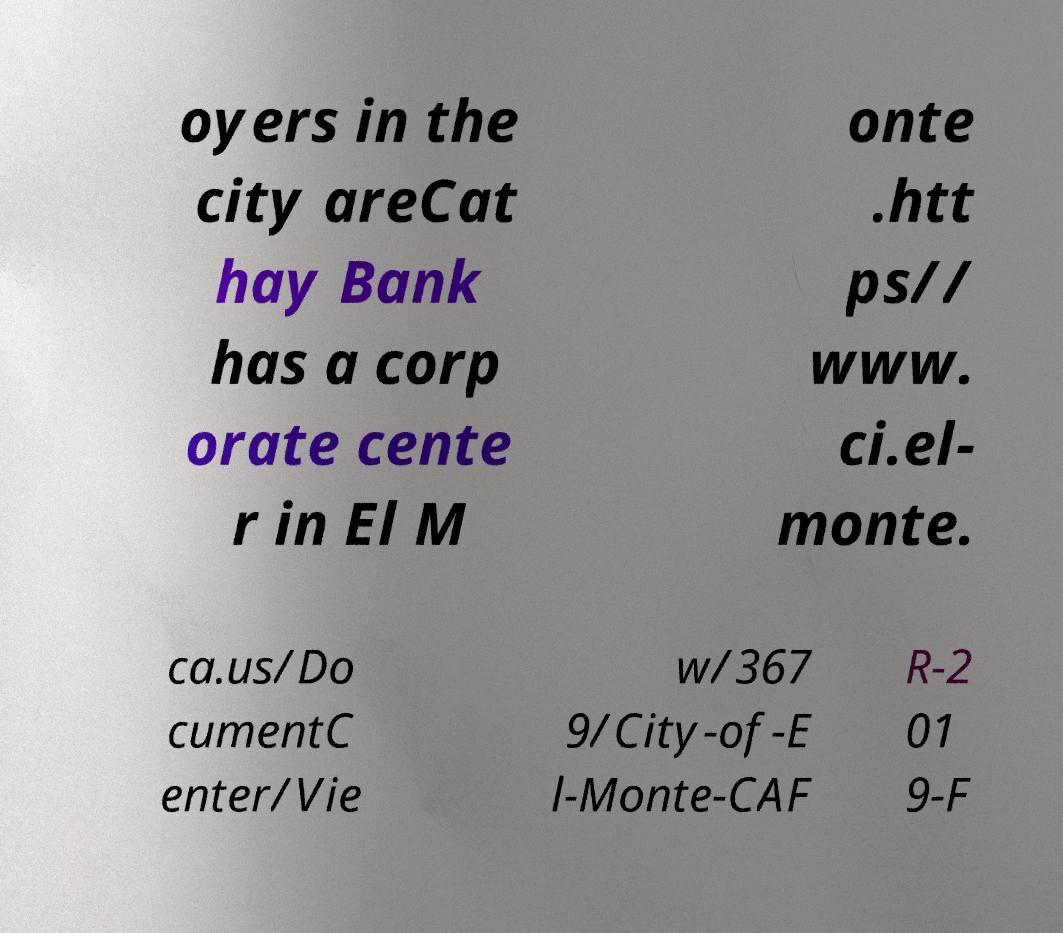Can you read and provide the text displayed in the image?This photo seems to have some interesting text. Can you extract and type it out for me? oyers in the city areCat hay Bank has a corp orate cente r in El M onte .htt ps// www. ci.el- monte. ca.us/Do cumentC enter/Vie w/367 9/City-of-E l-Monte-CAF R-2 01 9-F 